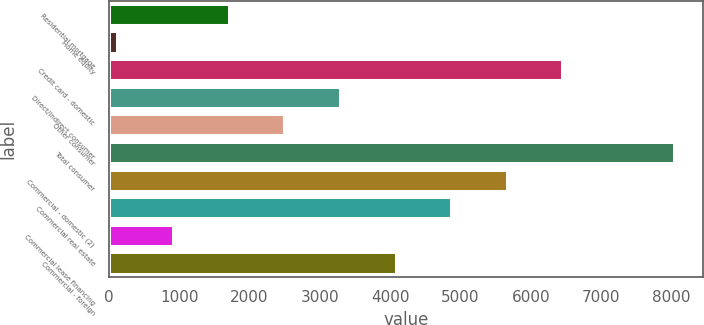<chart> <loc_0><loc_0><loc_500><loc_500><bar_chart><fcel>Residential mortgage<fcel>Home equity<fcel>Credit card - domestic<fcel>Direct/Indirect consumer<fcel>Other consumer<fcel>Total consumer<fcel>Commercial - domestic (2)<fcel>Commercial real estate<fcel>Commercial lease financing<fcel>Commercial - foreign<nl><fcel>1717.8<fcel>136<fcel>6463.2<fcel>3299.6<fcel>2508.7<fcel>8045<fcel>5672.3<fcel>4881.4<fcel>926.9<fcel>4090.5<nl></chart> 